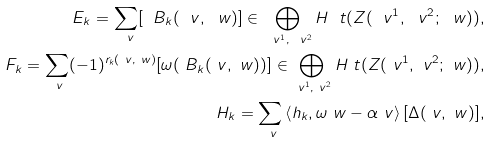<formula> <loc_0><loc_0><loc_500><loc_500>E _ { k } = \sum _ { \ v } [ \ B _ { k } ( \ v , \ w ) ] \in \bigoplus _ { \ v ^ { 1 } , \ v ^ { 2 } } H _ { \ } t ( Z ( \ v ^ { 1 } , \ v ^ { 2 } ; \ w ) ) , \\ F _ { k } = \sum _ { \ v } ( - 1 ) ^ { r _ { k } ( \ v , \ w ) } [ \omega ( \ B _ { k } ( \ v , \ w ) ) ] \in \bigoplus _ { \ v ^ { 1 } , \ v ^ { 2 } } H _ { \ } t ( Z ( \ v ^ { 1 } , \ v ^ { 2 } ; \ w ) ) , \\ H _ { k } = \sum _ { \ v } \left < h _ { k } , \omega _ { \ } w - \alpha _ { \ } v \right > [ \Delta ( \ v , \ w ) ] ,</formula> 